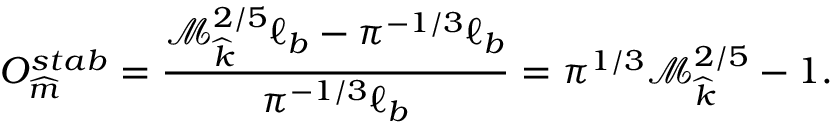Convert formula to latex. <formula><loc_0><loc_0><loc_500><loc_500>O _ { \widehat { m } } ^ { s t a b } = \frac { \mathcal { M } _ { \widehat { k } } ^ { 2 / 5 } \ell _ { b } - \pi ^ { - 1 / 3 } \ell _ { b } } { \pi ^ { - 1 / 3 } \ell _ { b } } = \pi ^ { 1 / 3 } \mathcal { M } _ { \widehat { k } } ^ { 2 / 5 } - 1 .</formula> 